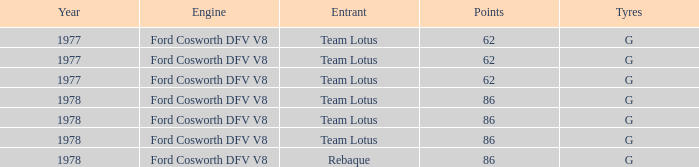What is the Focus that has a Year bigger than 1977? 86, 86, 86, 86. 